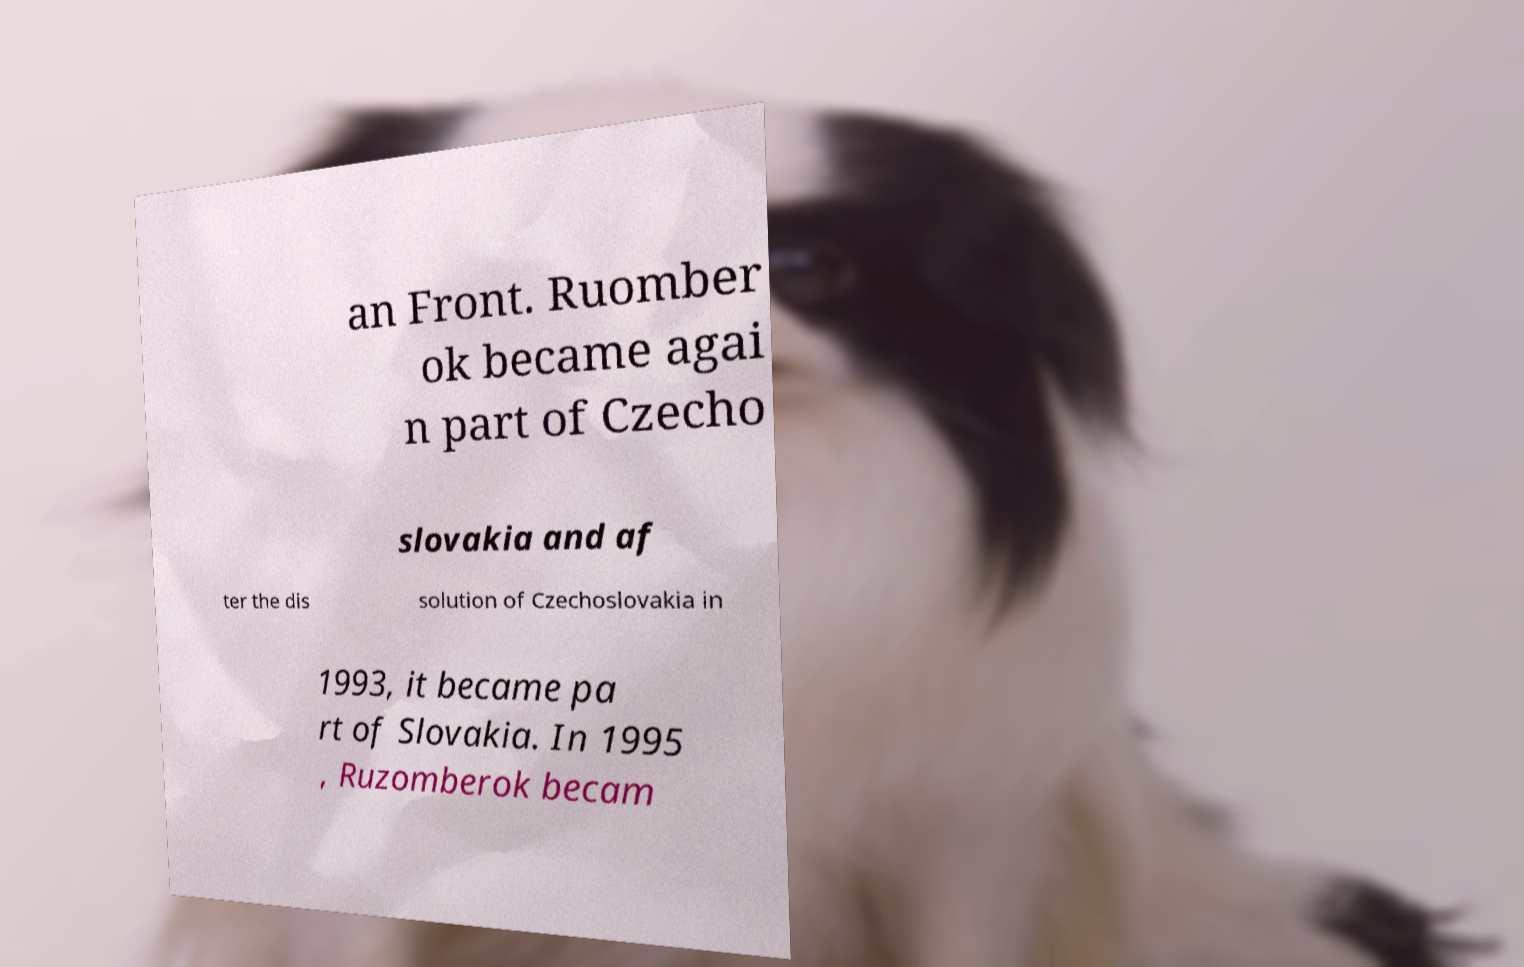Can you accurately transcribe the text from the provided image for me? an Front. Ruomber ok became agai n part of Czecho slovakia and af ter the dis solution of Czechoslovakia in 1993, it became pa rt of Slovakia. In 1995 , Ruzomberok becam 